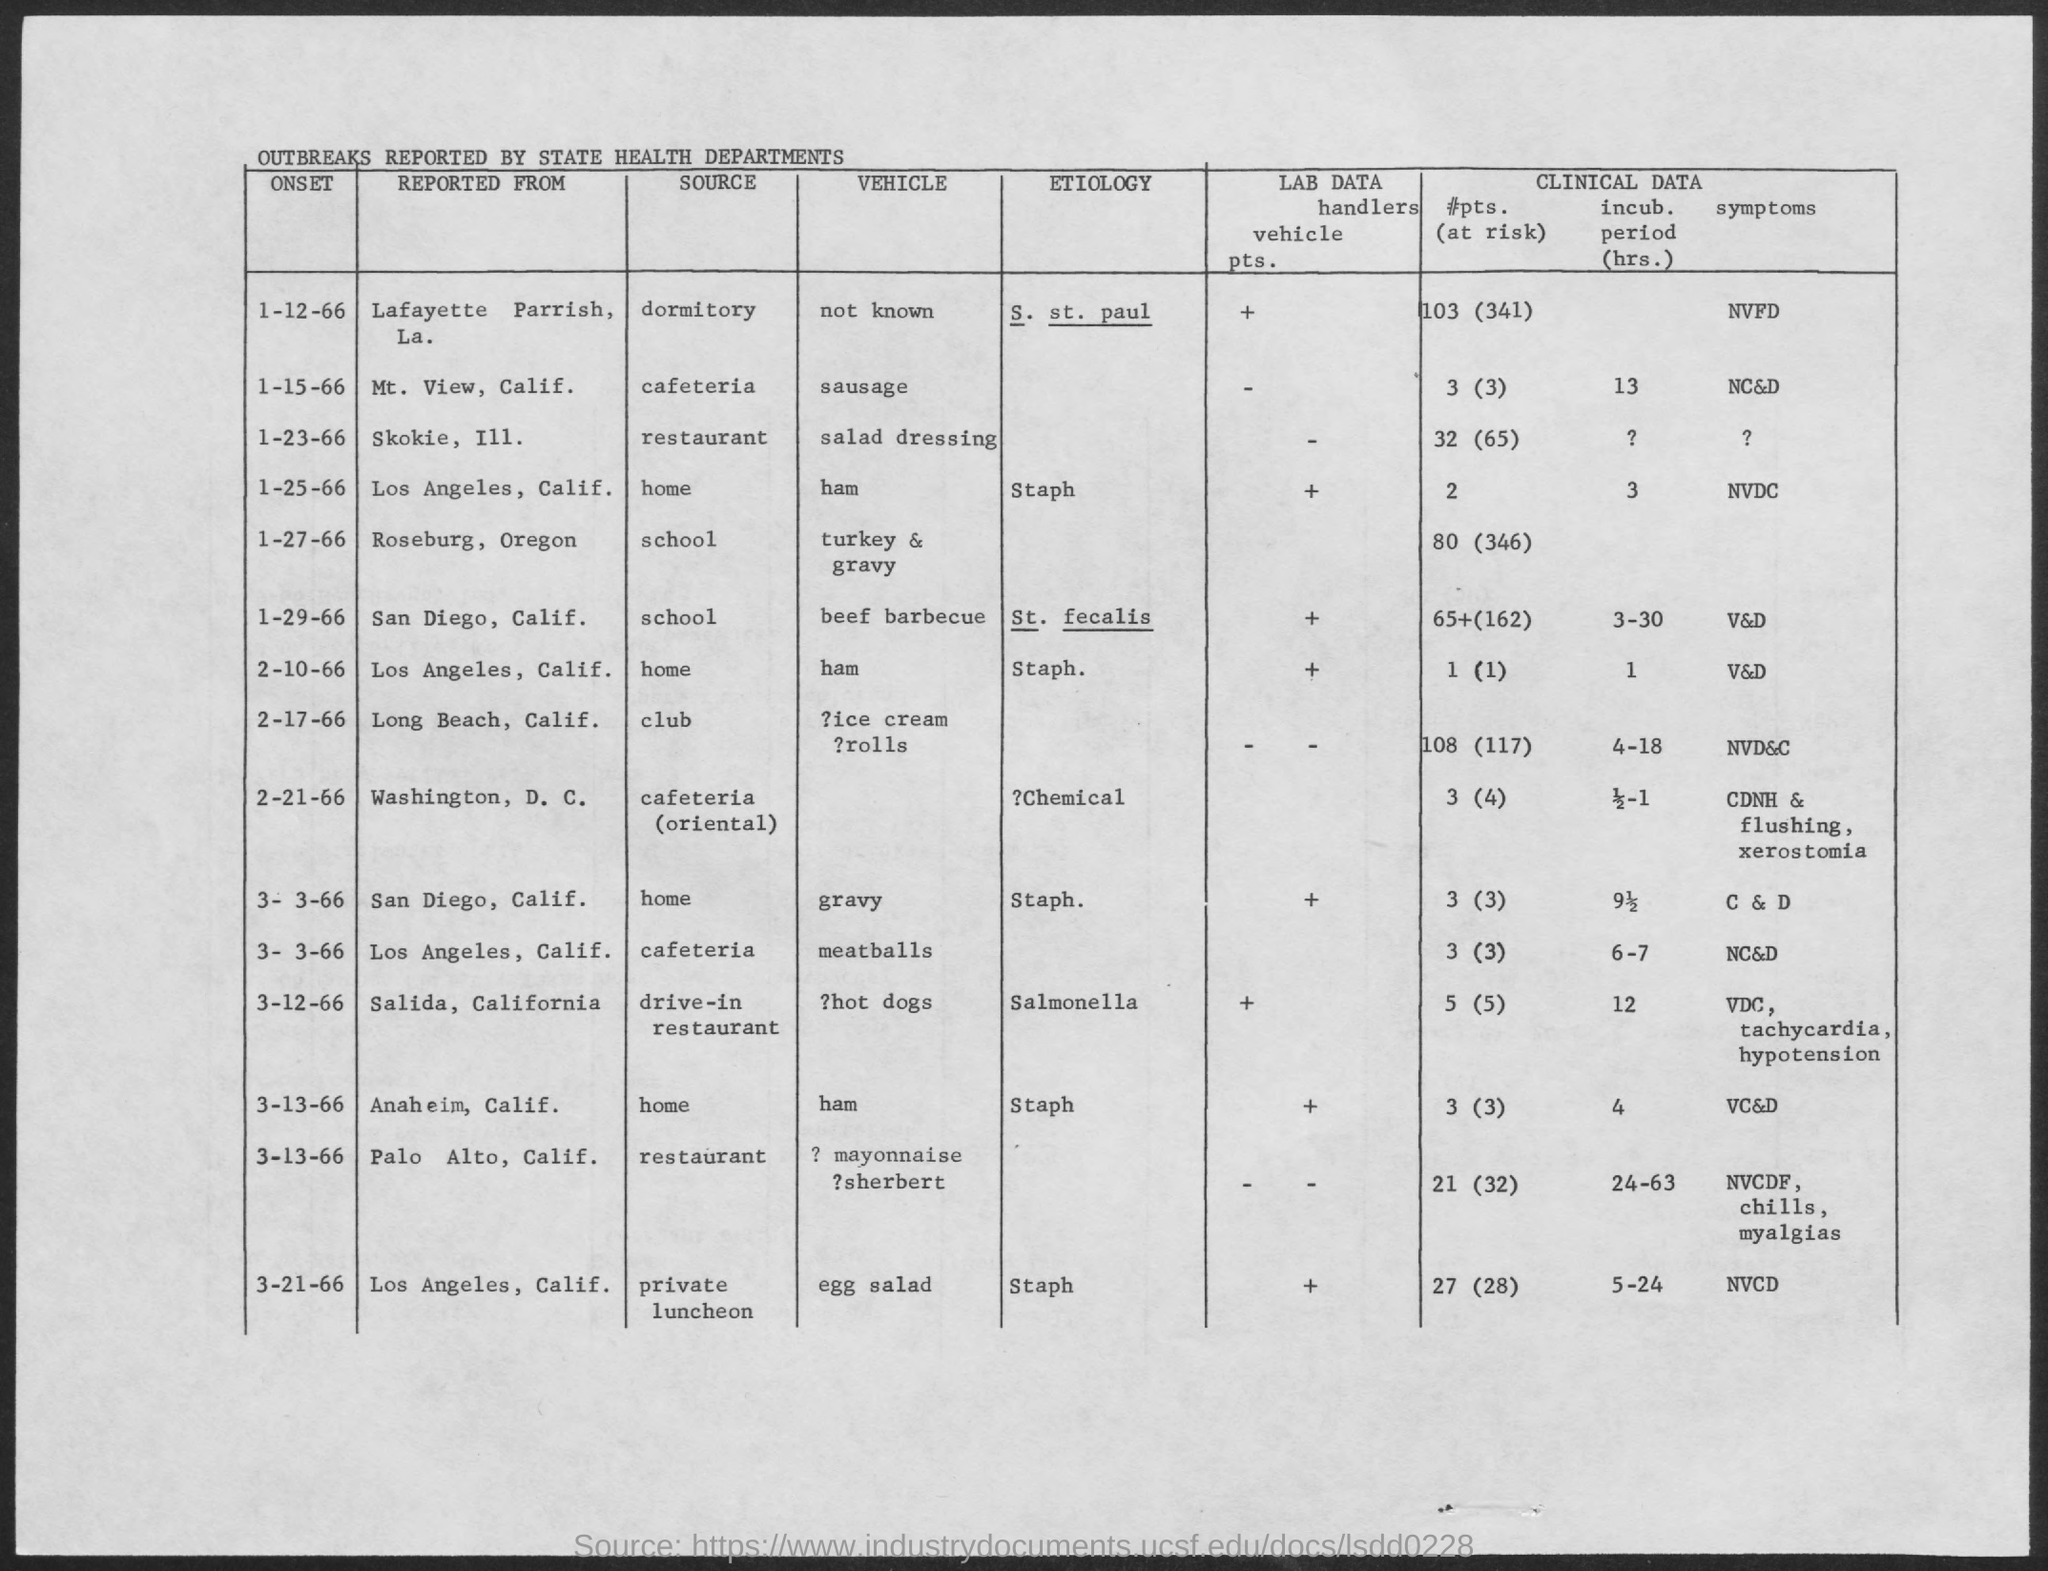Draw attention to some important aspects in this diagram. An outbreak of Salmonella Saint Paul has been reported in Lafayette Parrish, Louisiana. The etiology of this outbreak is S. Saint Paul. An outbreak of a specific source, reported to have originated from a restaurant located in Skokie, Illinois, has been identified. An outbreak of a vehicle has been reported from Skokie, Illinois. The source of the outbreak is believed to be salad dressing. The vehicle of the reported outbreak in Lafayette Parish, Louisiana is currently unknown. An outbreak of a disease has been reported to have originated from the cafeteria in Mount View, California. 